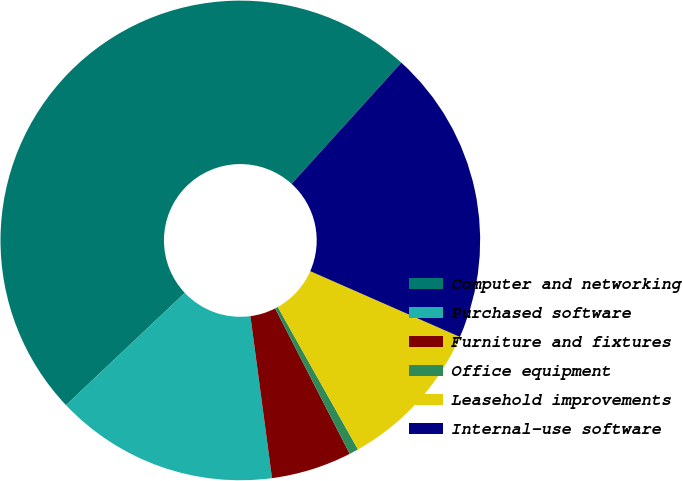<chart> <loc_0><loc_0><loc_500><loc_500><pie_chart><fcel>Computer and networking<fcel>Purchased software<fcel>Furniture and fixtures<fcel>Office equipment<fcel>Leasehold improvements<fcel>Internal-use software<nl><fcel>48.76%<fcel>15.06%<fcel>5.43%<fcel>0.62%<fcel>10.25%<fcel>19.88%<nl></chart> 